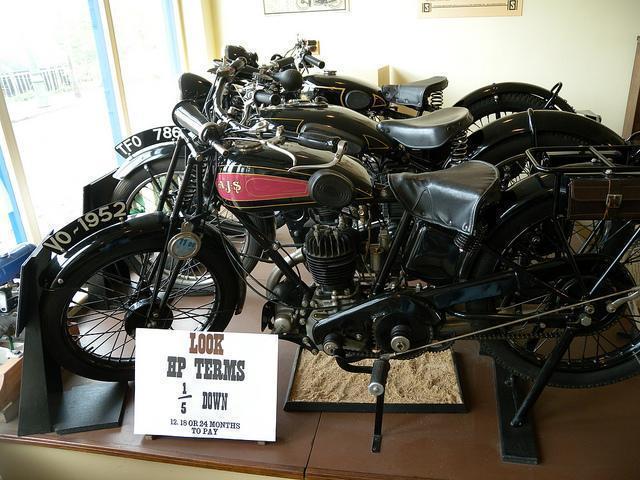What are the terms referring to?
Pick the correct solution from the four options below to address the question.
Options: Road rules, rider code, biker terms, financing. Financing. 